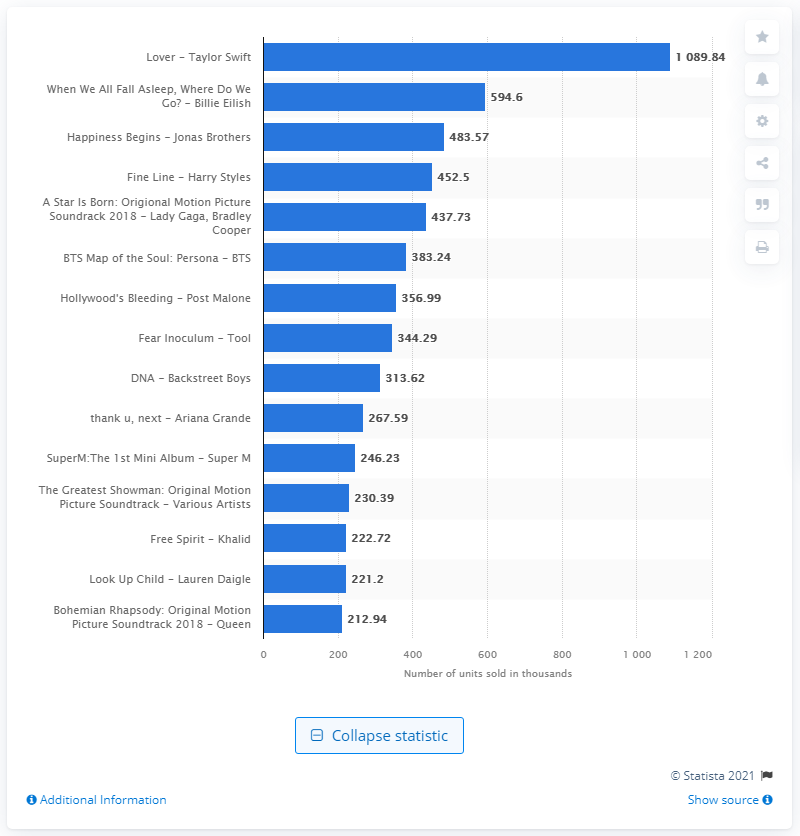Point out several critical features in this image. In the United States in 2019, "Lover" was sold a total of 1089.84 copies. Billie Eilish's album "When We All Fall Asleep, Where Do We Go?" has sold 594,600 copies. 